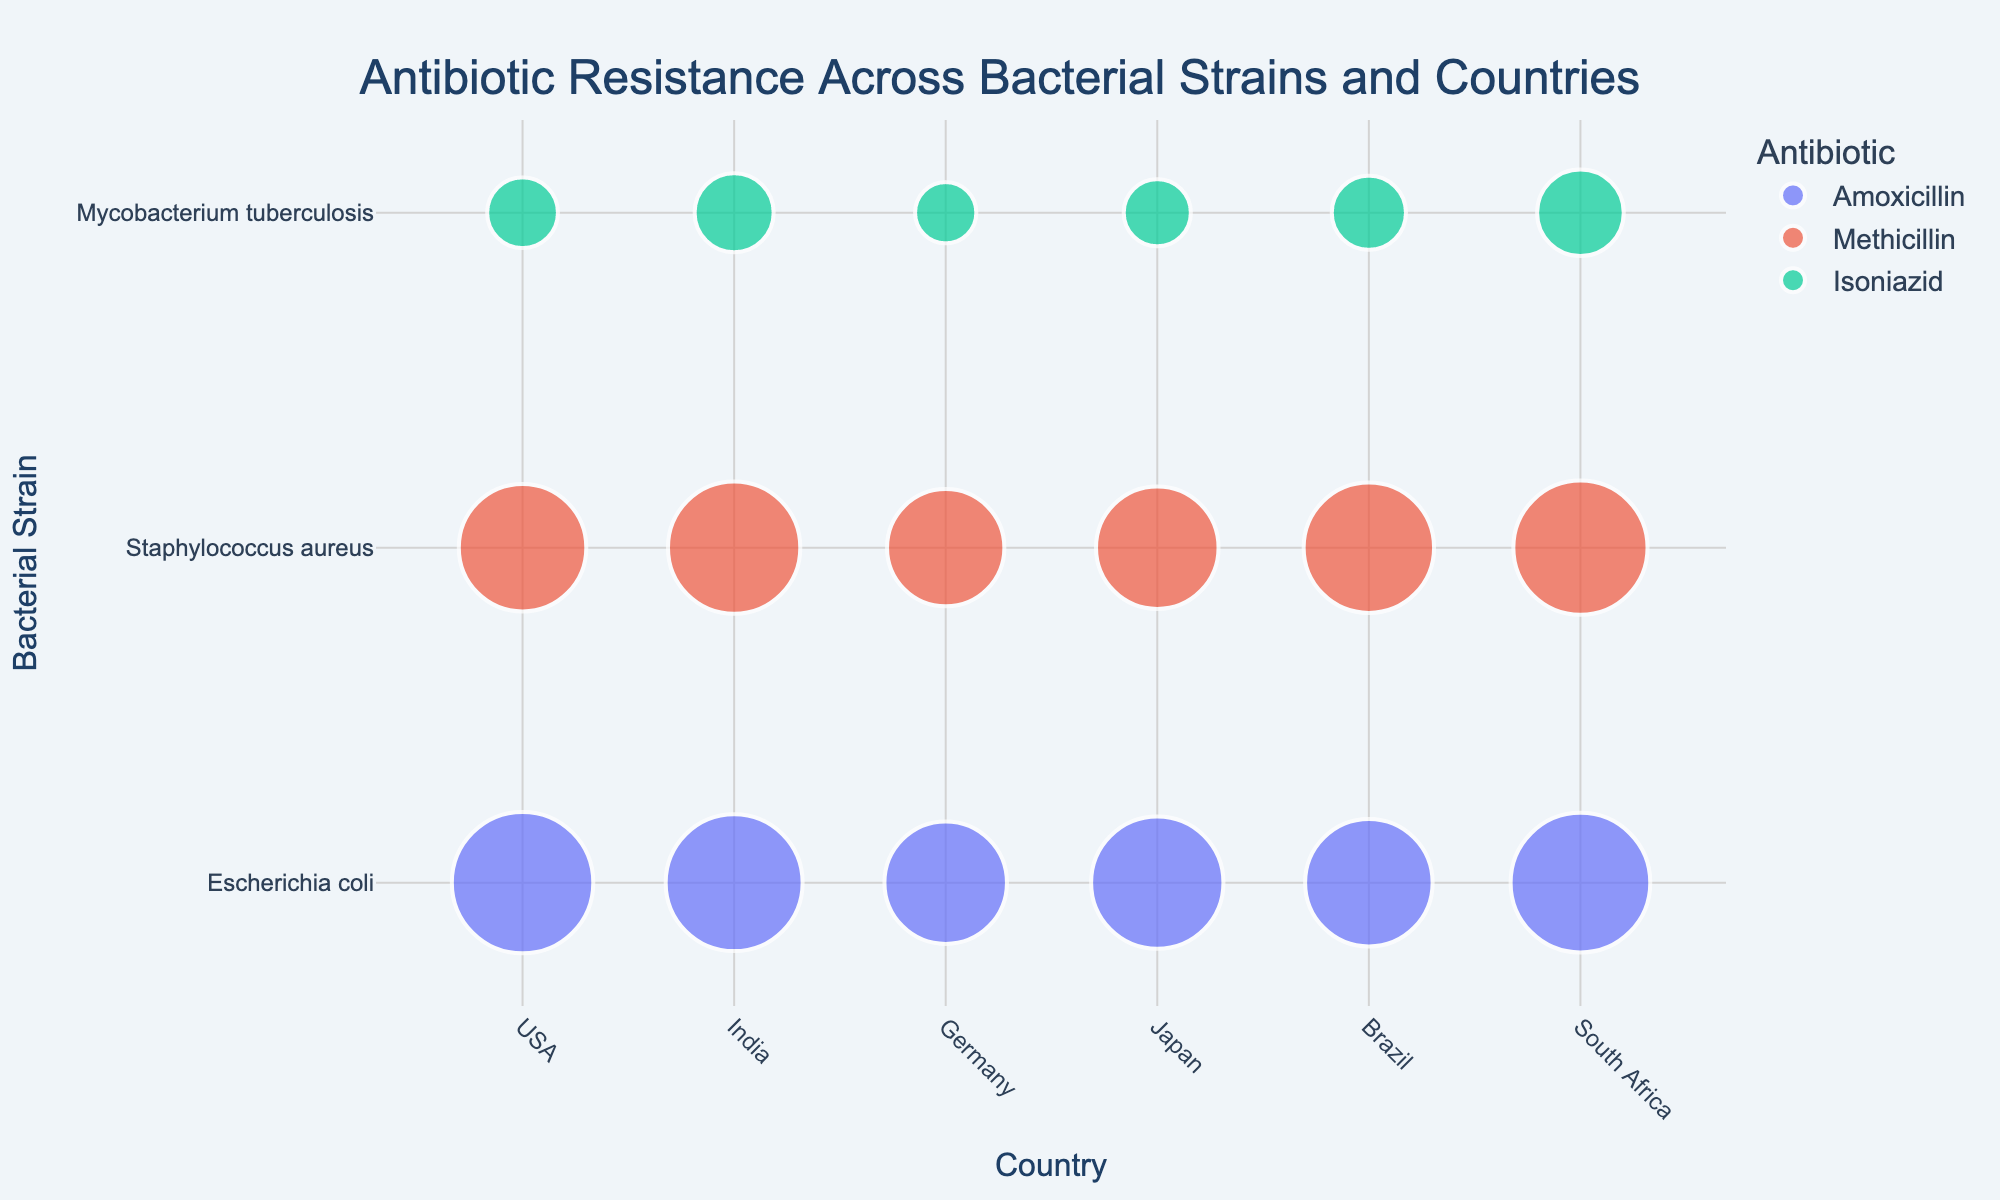Which country shows the highest resistance percentage for Methicillin in Staphylococcus aureus? To answer this, find the largest bubble among those colored for Methicillin and labeled for Staphylococcus aureus. South Africa has the highest percentage at 72%.
Answer: South Africa How does the resistance percentage of Escherichia coli to Amoxicillin in Germany compare to that in Brazil? Locate the bubbles for Escherichia coli under Germany and Brazil, both colored for Amoxicillin. Germany's resistance percentage is 60%, while Brazil's is 65%. Since 65% is greater than 60%, Brazil has a higher resistance.
Answer: Brazil's is higher Which country's Escherichia coli strain shows the lowest Amoxicillin resistance? Locate the smallest bubble for Escherichia coli under the Amoxicillin color. Germany has the lowest resistance percentage at 60%.
Answer: Germany What is the average resistance percentage of Isoniazid for Mycobacterium tuberculosis across all countries? Add the resistance percentages for Isoniazid in Mycobacterium tuberculosis for all countries and divide by the number of countries. (20 + 25 + 15 + 18 + 22 + 30)/6 = 21.67%
Answer: 21.67% Between India and Japan, which country shows a higher sample size for Methicillin resistance in Staphylococcus aureus? Compare the sample sizes visible in the hover data for Methicillin in Staphylococcus aureus between India and Japan. India has a sample size of 95, and Japan has 100. Japan has the higher sample size.
Answer: Japan Is the resistance percentage of Staphylococcus aureus to Methicillin generally higher or lower compared to Mycobacterium tuberculosis to Isoniazid within most countries? Compare the bubble sizes for Methicillin in Staphylococcus aureus to those for Isoniazid in Mycobacterium tuberculosis within each country. Generally, the bubbles for Methicillin are larger, indicating higher resistance percentages.
Answer: Higher Which antibiotic shows the most variability in resistance percentages across all bacterial strains and countries? Assess the bubbles' sizes (represent resistance percentages) across all antibiotics. Amoxicillin's resistance percentages range widely from 60% to 80%, suggesting the most variability.
Answer: Amoxicillin What is the total sample size for Escherichia coli tested with Amoxicillin across all countries? Sum the sample sizes for Escherichia coli tested with Amoxicillin in all countries: 100 (USA) + 105 (India) + 80 (Germany) + 90 (Japan) + 95 (Brazil) + 83 (South Africa) = 553
Answer: 553 Does South Africa have the highest resistance percentage for any antibiotic-bacterial strain combination? Check if any bubble under South Africa is the largest compared to other countries for specific antibiotic-bacterial strain combinations. South Africa has the highest percentage (72%) for Methicillin in Staphylococcus aureus.
Answer: Yes What is the resistance percentage difference between the highest and lowest percentages for Isoniazid in Mycobacterium tuberculosis? Identify the highest and lowest resistance percentages for Isoniazid in Mycobacterium tuberculosis. The highest is 30% in South Africa and the lowest is 15% in Germany. The difference is 30% - 15% = 15%.
Answer: 15% 